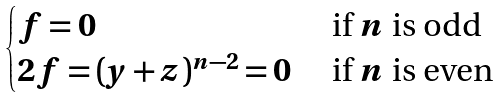<formula> <loc_0><loc_0><loc_500><loc_500>\begin{cases} f = 0 & \text { if $n$ is odd } \\ 2 f = ( y + z ) ^ { n - 2 } = 0 & \text { if $n$ is even } \end{cases}</formula> 